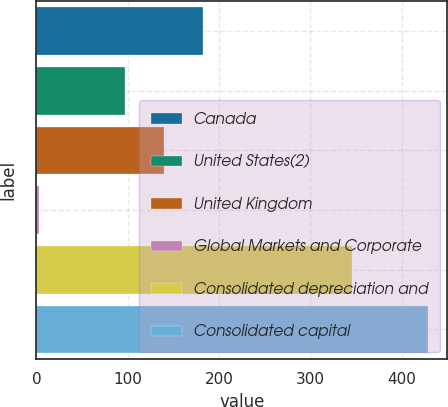Convert chart. <chart><loc_0><loc_0><loc_500><loc_500><bar_chart><fcel>Canada<fcel>United States(2)<fcel>United Kingdom<fcel>Global Markets and Corporate<fcel>Consolidated depreciation and<fcel>Consolidated capital<nl><fcel>182.48<fcel>97.4<fcel>139.94<fcel>2.9<fcel>345.8<fcel>428.3<nl></chart> 